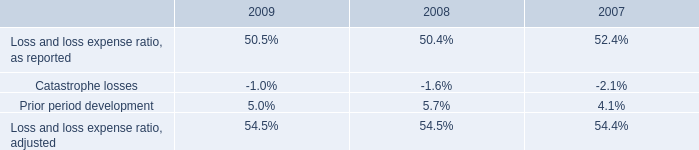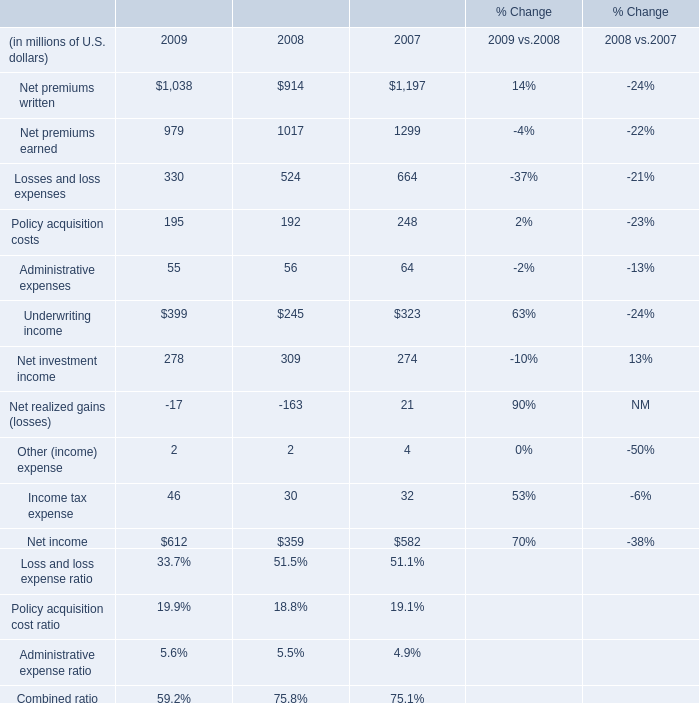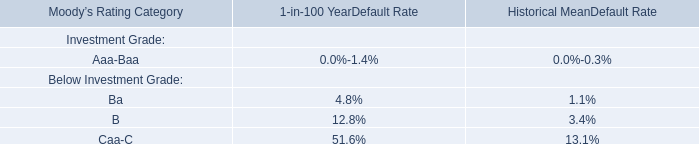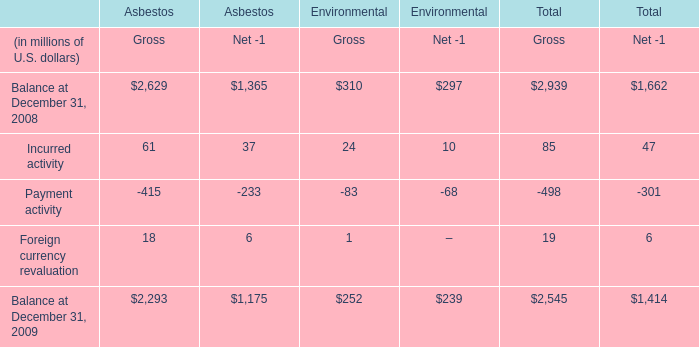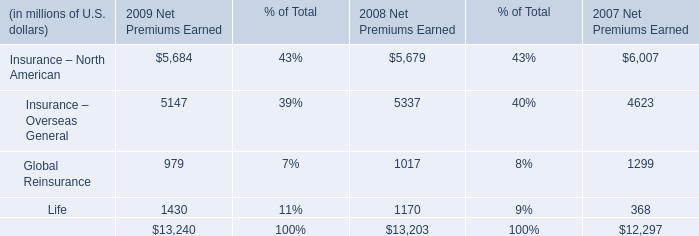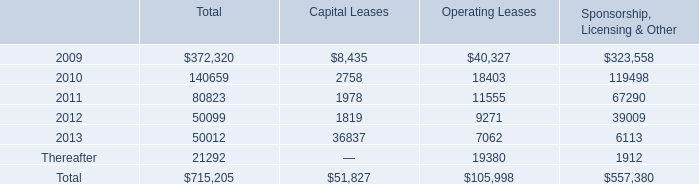Which year / section is Net premiums earned the lowest? 
Answer: 2009. 